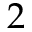<formula> <loc_0><loc_0><loc_500><loc_500>2</formula> 